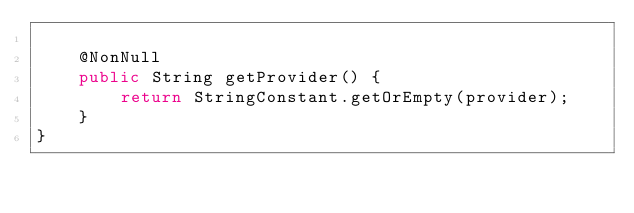Convert code to text. <code><loc_0><loc_0><loc_500><loc_500><_Java_>
    @NonNull
    public String getProvider() {
        return StringConstant.getOrEmpty(provider);
    }
}
</code> 